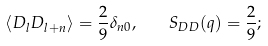Convert formula to latex. <formula><loc_0><loc_0><loc_500><loc_500>\langle D _ { l } D _ { l + n } \rangle = \frac { 2 } { 9 } \delta _ { n 0 } , \quad S _ { D D } ( q ) = \frac { 2 } { 9 } ;</formula> 